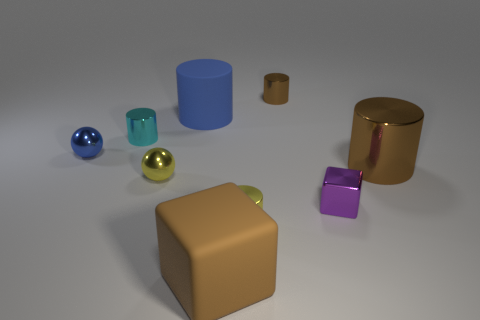What number of cyan objects are big objects or small blocks?
Make the answer very short. 0. There is a tiny object that is the same color as the rubber cube; what is its shape?
Give a very brief answer. Cylinder. There is a rubber thing that is in front of the purple block; is it the same shape as the purple metallic thing right of the yellow cylinder?
Ensure brevity in your answer.  Yes. What number of large cyan blocks are there?
Your response must be concise. 0. There is a blue thing that is made of the same material as the brown cube; what is its shape?
Offer a very short reply. Cylinder. Is there anything else that is the same color as the tiny shiny block?
Make the answer very short. No. There is a matte block; is it the same color as the tiny shiny sphere in front of the blue metal thing?
Provide a succinct answer. No. Is the number of metal cubes that are in front of the metallic block less than the number of tiny cyan cylinders?
Ensure brevity in your answer.  Yes. What is the material of the blue thing left of the big blue rubber cylinder?
Make the answer very short. Metal. What number of other things are the same size as the purple metal thing?
Provide a succinct answer. 5. 